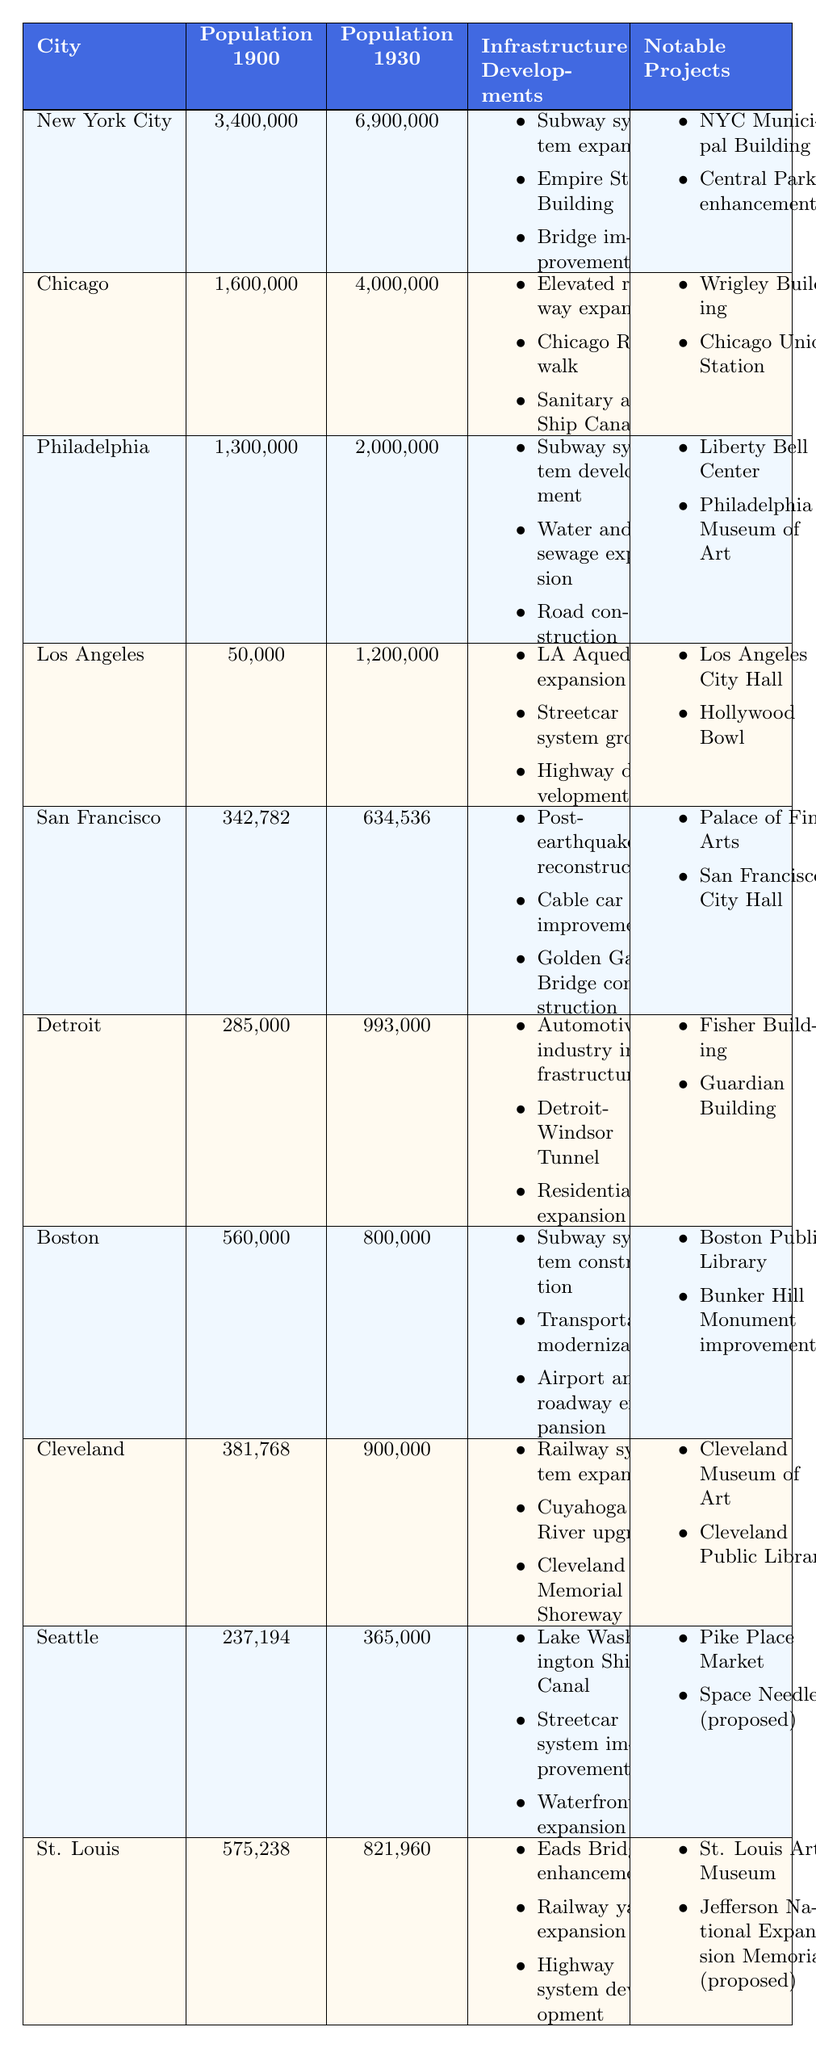What was the population growth in New York City from 1900 to 1930? The population in New York City in 1900 was 3,400,000 and in 1930 it was 6,900,000. The growth is calculated as 6,900,000 - 3,400,000 = 3,500,000.
Answer: 3,500,000 Which city had the highest population in 1930? By comparing the populations in the table, New York City had the highest population in 1930 at 6,900,000.
Answer: New York City Did Philadelphia have more notable infrastructure projects than Boston? Philadelphia has two notable infrastructure projects while Boston also has two notable projects. Therefore, they are equal.
Answer: No What was the total population of the four largest cities in 1930? The four largest cities in 1930 are New York City (6,900,000), Chicago (4,000,000), Philadelphia (2,000,000), and Los Angeles (1,200,000). Summing these gives 6,900,000 + 4,000,000 + 2,000,000 + 1,200,000 = 14,100,000.
Answer: 14,100,000 Which city experienced the smallest population increase from 1900 to 1930, and what was that increase? By analyzing the population increases: New York City (3,500,000), Chicago (2,400,000), Philadelphia (700,000), Los Angeles (1,150,000), San Francisco (291,754), Detroit (708,000), Boston (240,000), Cleveland (518,232), Seattle (127,806), and St. Louis (246,722). The smallest increase was in Boston at 240,000.
Answer: Boston; 240,000 Which city had significant enhancements to its cable car system? The city listed with improvements to the cable car system is San Francisco.
Answer: San Francisco Did all cities have infrastructure developments regarding their subway systems between 1900 and 1930? No, not all cities had such developments; for example, cities like Detroit and Los Angeles did not mention subway system developments in their infrastructure developments.
Answer: No Which city had both a subway system and a municipal building completed in the early 20th century? Philadelphia developed a subway system in 1910 and has the Liberty Bell Center completed in 1926.
Answer: Philadelphia What was the difference in population size between Cleveland and Detroit in 1930? The population in Cleveland in 1930 was 900,000 and in Detroit it was 993,000. The difference is 993,000 - 900,000 = 93,000.
Answer: 93,000 After the 1906 earthquake, which city's cable car system was improved? San Francisco's cable car system was improved following the reconstruction after the 1906 earthquake.
Answer: San Francisco What infrastructure development was unique to Los Angeles in this time period? The expansion of the Los Angeles Aqueduct, completed in 1913, was a unique development for Los Angeles during this period.
Answer: Expansion of the Los Angeles Aqueduct 